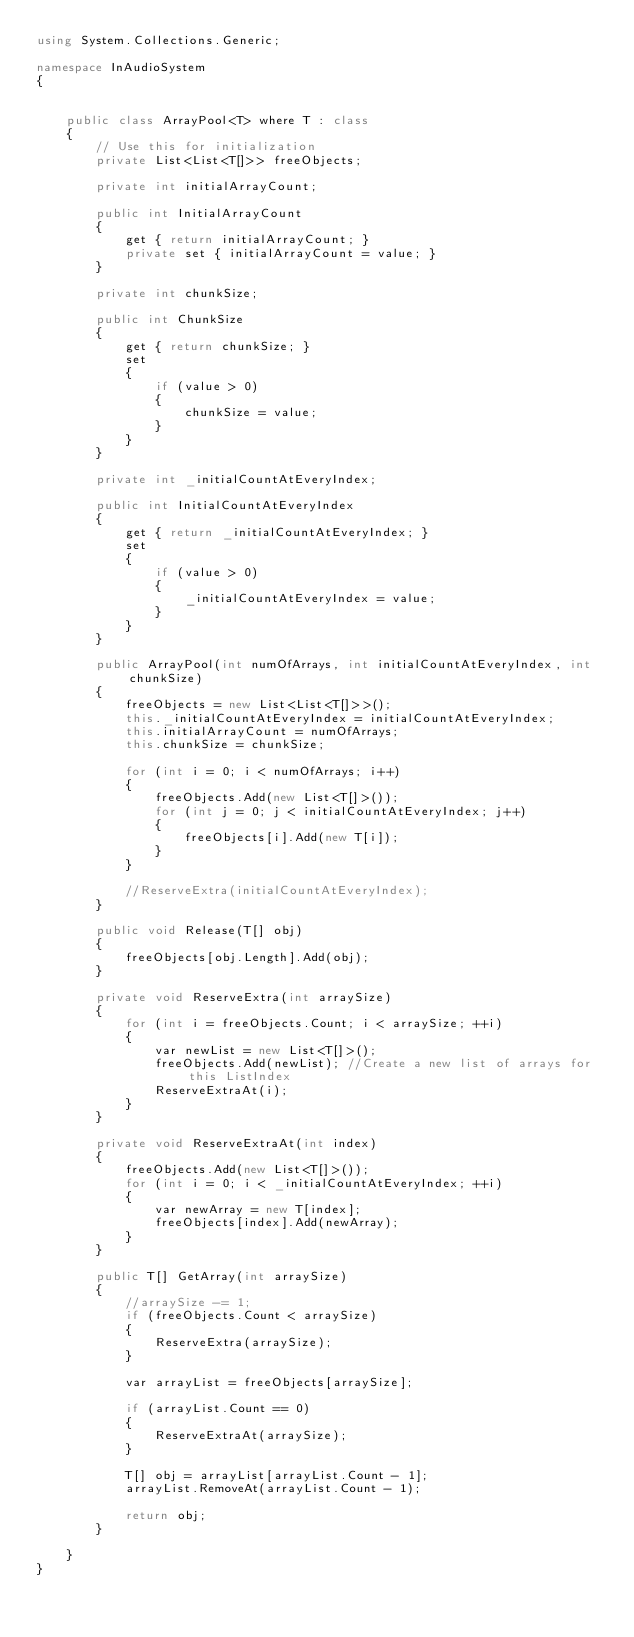<code> <loc_0><loc_0><loc_500><loc_500><_C#_>using System.Collections.Generic;

namespace InAudioSystem
{


    public class ArrayPool<T> where T : class
    {
        // Use this for initialization
        private List<List<T[]>> freeObjects;

        private int initialArrayCount;

        public int InitialArrayCount
        {
            get { return initialArrayCount; }
            private set { initialArrayCount = value; }
        }

        private int chunkSize;

        public int ChunkSize
        {
            get { return chunkSize; }
            set
            {
                if (value > 0)
                {
                    chunkSize = value;
                }
            }
        }

        private int _initialCountAtEveryIndex;

        public int InitialCountAtEveryIndex
        {
            get { return _initialCountAtEveryIndex; }
            set
            {
                if (value > 0)
                {
                    _initialCountAtEveryIndex = value;
                }
            }
        }

        public ArrayPool(int numOfArrays, int initialCountAtEveryIndex, int chunkSize)
        {
            freeObjects = new List<List<T[]>>();
            this._initialCountAtEveryIndex = initialCountAtEveryIndex;
            this.initialArrayCount = numOfArrays;
            this.chunkSize = chunkSize;

            for (int i = 0; i < numOfArrays; i++)
            {
                freeObjects.Add(new List<T[]>());
                for (int j = 0; j < initialCountAtEveryIndex; j++)
                {
                    freeObjects[i].Add(new T[i]);
                }
            }

            //ReserveExtra(initialCountAtEveryIndex);
        }

        public void Release(T[] obj)
        {
            freeObjects[obj.Length].Add(obj);
        }

        private void ReserveExtra(int arraySize)
        {
            for (int i = freeObjects.Count; i < arraySize; ++i)
            {
                var newList = new List<T[]>();
                freeObjects.Add(newList); //Create a new list of arrays for this ListIndex
                ReserveExtraAt(i);
            }
        }

        private void ReserveExtraAt(int index)
        {
            freeObjects.Add(new List<T[]>());
            for (int i = 0; i < _initialCountAtEveryIndex; ++i)
            {
                var newArray = new T[index];
                freeObjects[index].Add(newArray);
            }
        }

        public T[] GetArray(int arraySize)
        {
            //arraySize -= 1;
            if (freeObjects.Count < arraySize)
            {
                ReserveExtra(arraySize);
            }

            var arrayList = freeObjects[arraySize];

            if (arrayList.Count == 0)
            {
                ReserveExtraAt(arraySize);
            }

            T[] obj = arrayList[arrayList.Count - 1];
            arrayList.RemoveAt(arrayList.Count - 1);

            return obj;
        }

    }
}</code> 